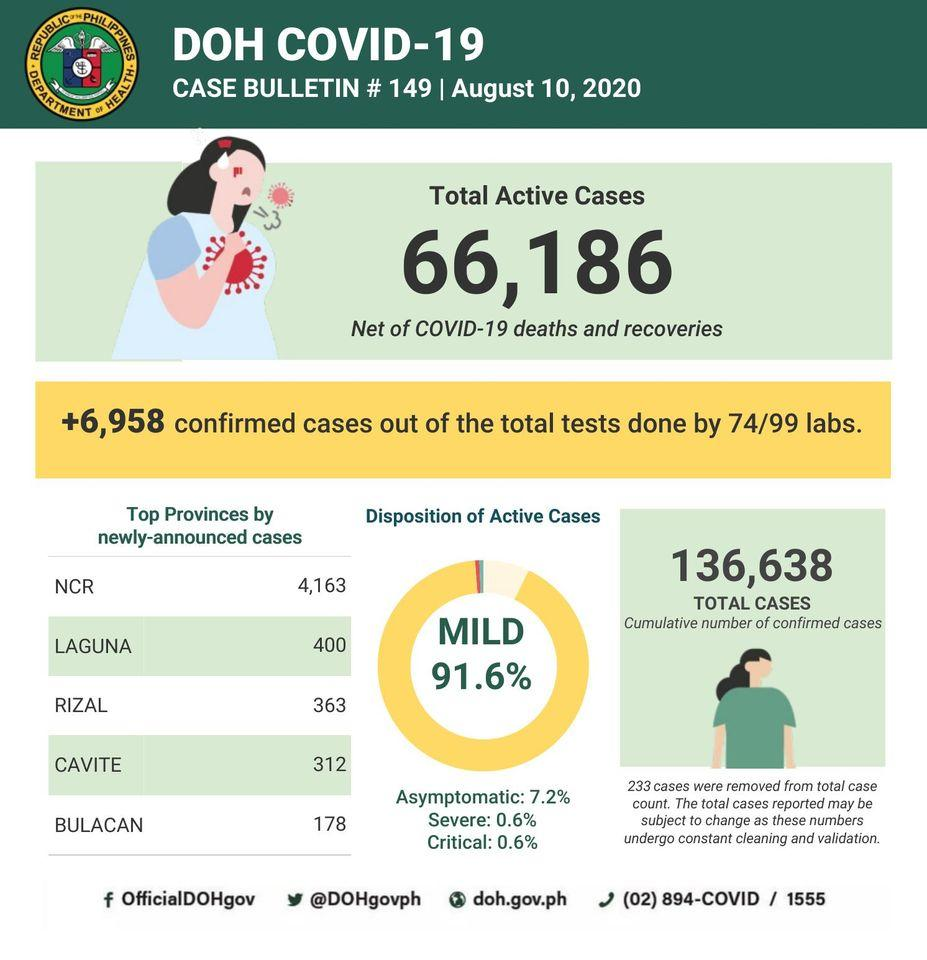Indicate a few pertinent items in this graphic. Eight point four percent of cases are not mild. Bulacan province has the least number of newly announced cases among all provinces. The Twitter handle provided is "@DOHgovph.. 